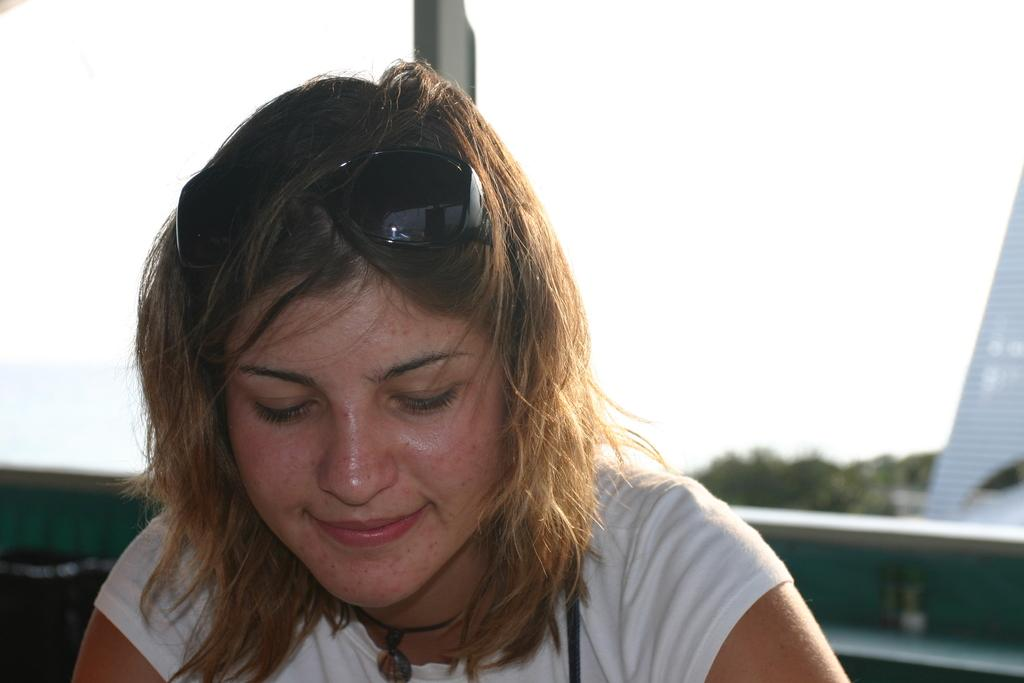Who is present in the image? There are women in the image. What are the women doing in the image? The women are seated and smiling. What accessory can be seen in the image? Sunglasses are visible in the image. What type of natural environment is present in the image? There are trees in the image. How would you describe the weather in the image? The sky is cloudy in the image. What type of wire is being used by the owl in the image? There is no owl present in the image, and therefore no wire being used by an owl. 